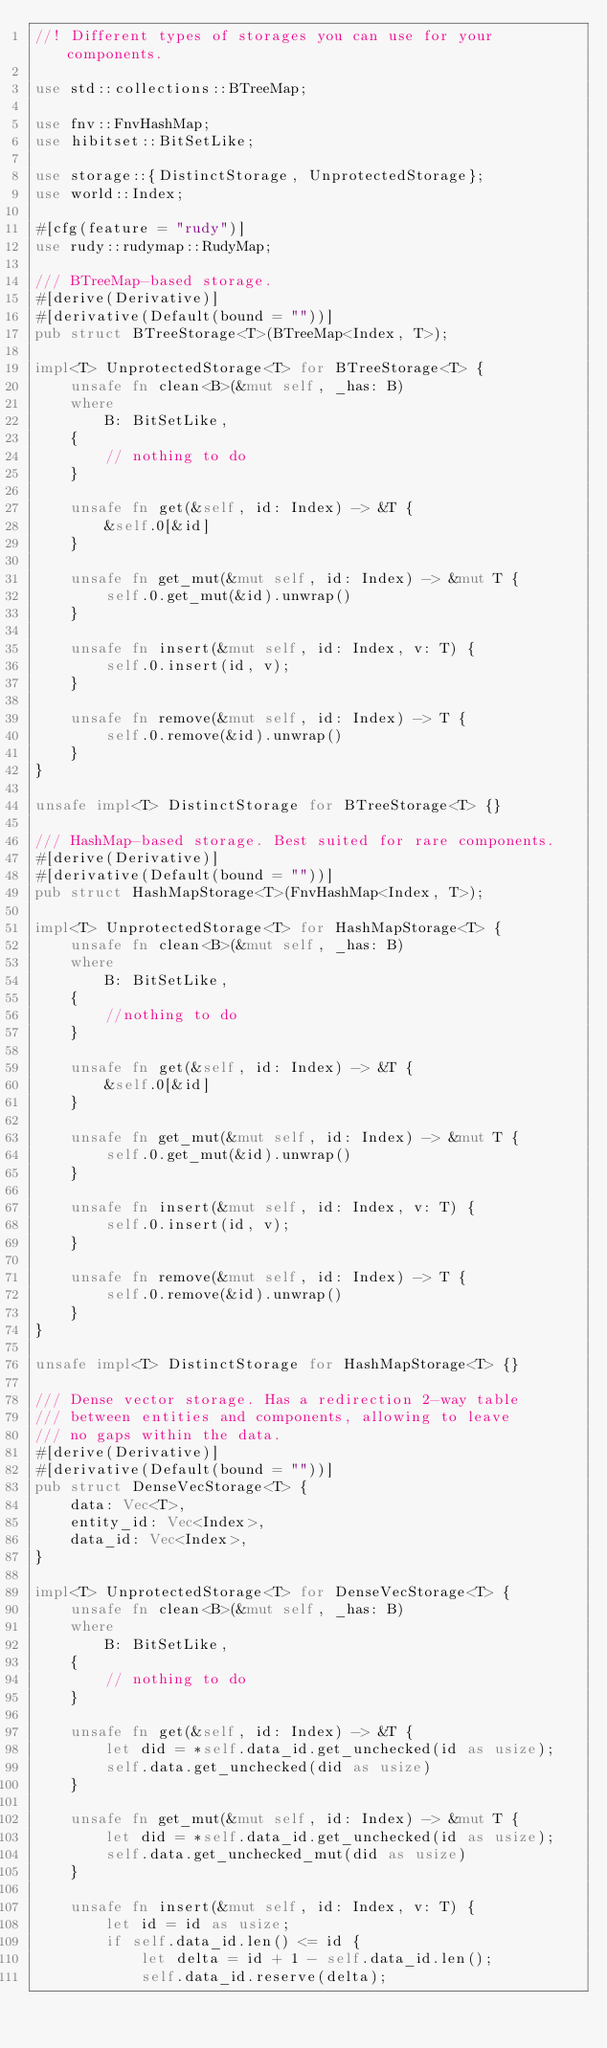<code> <loc_0><loc_0><loc_500><loc_500><_Rust_>//! Different types of storages you can use for your components.

use std::collections::BTreeMap;

use fnv::FnvHashMap;
use hibitset::BitSetLike;

use storage::{DistinctStorage, UnprotectedStorage};
use world::Index;

#[cfg(feature = "rudy")]
use rudy::rudymap::RudyMap;

/// BTreeMap-based storage.
#[derive(Derivative)]
#[derivative(Default(bound = ""))]
pub struct BTreeStorage<T>(BTreeMap<Index, T>);

impl<T> UnprotectedStorage<T> for BTreeStorage<T> {
    unsafe fn clean<B>(&mut self, _has: B)
    where
        B: BitSetLike,
    {
        // nothing to do
    }

    unsafe fn get(&self, id: Index) -> &T {
        &self.0[&id]
    }

    unsafe fn get_mut(&mut self, id: Index) -> &mut T {
        self.0.get_mut(&id).unwrap()
    }

    unsafe fn insert(&mut self, id: Index, v: T) {
        self.0.insert(id, v);
    }

    unsafe fn remove(&mut self, id: Index) -> T {
        self.0.remove(&id).unwrap()
    }
}

unsafe impl<T> DistinctStorage for BTreeStorage<T> {}

/// HashMap-based storage. Best suited for rare components.
#[derive(Derivative)]
#[derivative(Default(bound = ""))]
pub struct HashMapStorage<T>(FnvHashMap<Index, T>);

impl<T> UnprotectedStorage<T> for HashMapStorage<T> {
    unsafe fn clean<B>(&mut self, _has: B)
    where
        B: BitSetLike,
    {
        //nothing to do
    }

    unsafe fn get(&self, id: Index) -> &T {
        &self.0[&id]
    }

    unsafe fn get_mut(&mut self, id: Index) -> &mut T {
        self.0.get_mut(&id).unwrap()
    }

    unsafe fn insert(&mut self, id: Index, v: T) {
        self.0.insert(id, v);
    }

    unsafe fn remove(&mut self, id: Index) -> T {
        self.0.remove(&id).unwrap()
    }
}

unsafe impl<T> DistinctStorage for HashMapStorage<T> {}

/// Dense vector storage. Has a redirection 2-way table
/// between entities and components, allowing to leave
/// no gaps within the data.
#[derive(Derivative)]
#[derivative(Default(bound = ""))]
pub struct DenseVecStorage<T> {
    data: Vec<T>,
    entity_id: Vec<Index>,
    data_id: Vec<Index>,
}

impl<T> UnprotectedStorage<T> for DenseVecStorage<T> {
    unsafe fn clean<B>(&mut self, _has: B)
    where
        B: BitSetLike,
    {
        // nothing to do
    }

    unsafe fn get(&self, id: Index) -> &T {
        let did = *self.data_id.get_unchecked(id as usize);
        self.data.get_unchecked(did as usize)
    }

    unsafe fn get_mut(&mut self, id: Index) -> &mut T {
        let did = *self.data_id.get_unchecked(id as usize);
        self.data.get_unchecked_mut(did as usize)
    }

    unsafe fn insert(&mut self, id: Index, v: T) {
        let id = id as usize;
        if self.data_id.len() <= id {
            let delta = id + 1 - self.data_id.len();
            self.data_id.reserve(delta);</code> 